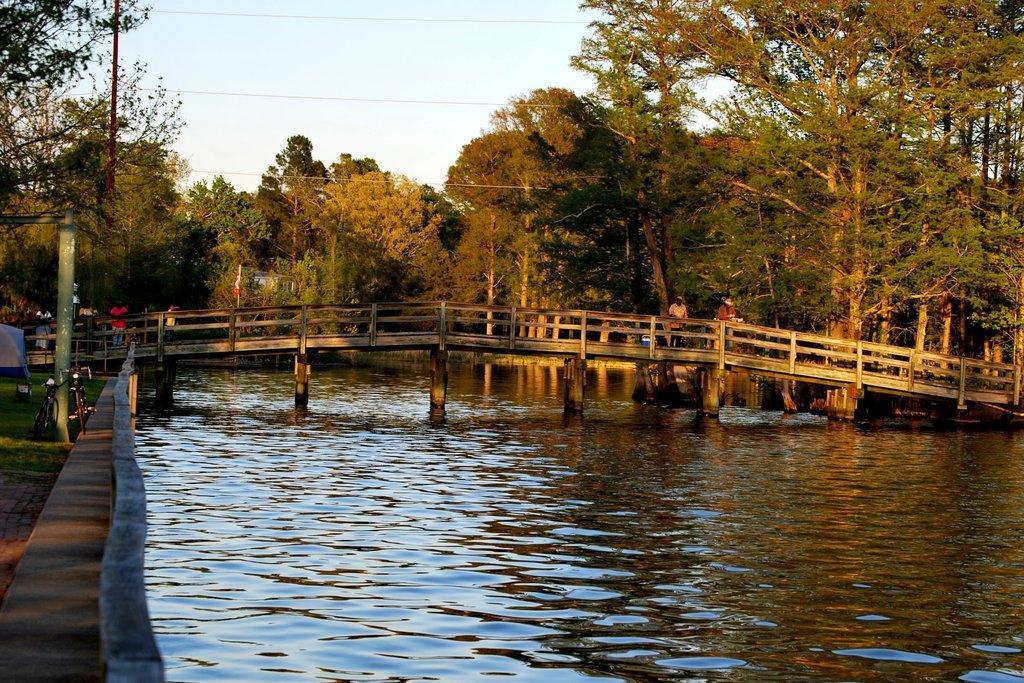How would you summarize this image in a sentence or two? In this image I can see at the bottom there is water in the middle there is a bridge few people are standing on it. In the background there are trees. At the top there is the sky. 